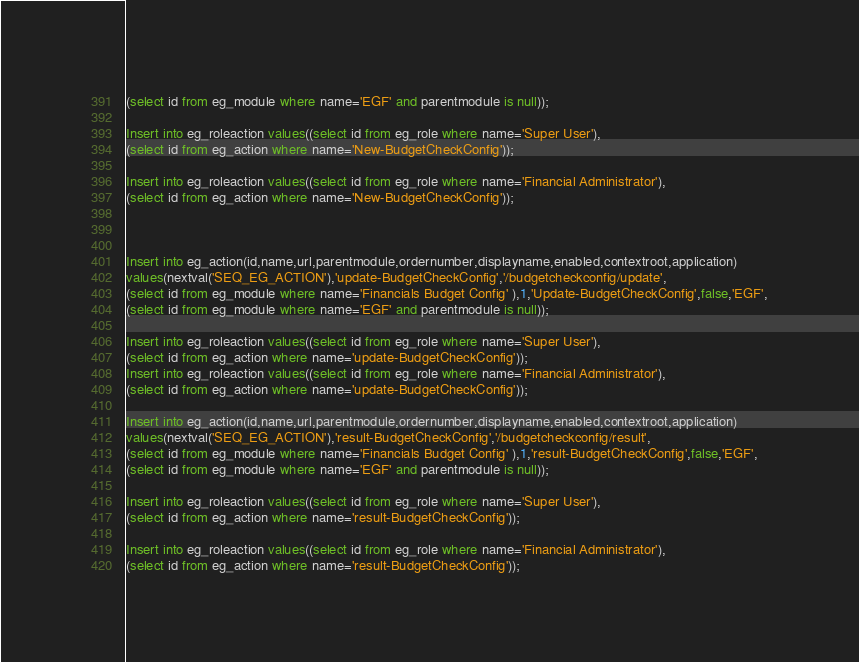Convert code to text. <code><loc_0><loc_0><loc_500><loc_500><_SQL_>(select id from eg_module where name='EGF' and parentmodule is null));

Insert into eg_roleaction values((select id from eg_role where name='Super User'),
(select id from eg_action where name='New-BudgetCheckConfig')); 

Insert into eg_roleaction values((select id from eg_role where name='Financial Administrator'),
(select id from eg_action where name='New-BudgetCheckConfig'));     



Insert into eg_action(id,name,url,parentmodule,ordernumber,displayname,enabled,contextroot,application)
values(nextval('SEQ_EG_ACTION'),'update-BudgetCheckConfig','/budgetcheckconfig/update',
(select id from eg_module where name='Financials Budget Config' ),1,'Update-BudgetCheckConfig',false,'EGF',
(select id from eg_module where name='EGF' and parentmodule is null));

Insert into eg_roleaction values((select id from eg_role where name='Super User'),
(select id from eg_action where name='update-BudgetCheckConfig'));  
Insert into eg_roleaction values((select id from eg_role where name='Financial Administrator'),
(select id from eg_action where name='update-BudgetCheckConfig'));  
 
Insert into eg_action(id,name,url,parentmodule,ordernumber,displayname,enabled,contextroot,application)
values(nextval('SEQ_EG_ACTION'),'result-BudgetCheckConfig','/budgetcheckconfig/result',
(select id from eg_module where name='Financials Budget Config' ),1,'result-BudgetCheckConfig',false,'EGF',
(select id from eg_module where name='EGF' and parentmodule is null));

Insert into eg_roleaction values((select id from eg_role where name='Super User'),
(select id from eg_action where name='result-BudgetCheckConfig'));  
 
Insert into eg_roleaction values((select id from eg_role where name='Financial Administrator'),
(select id from eg_action where name='result-BudgetCheckConfig'));  

</code> 